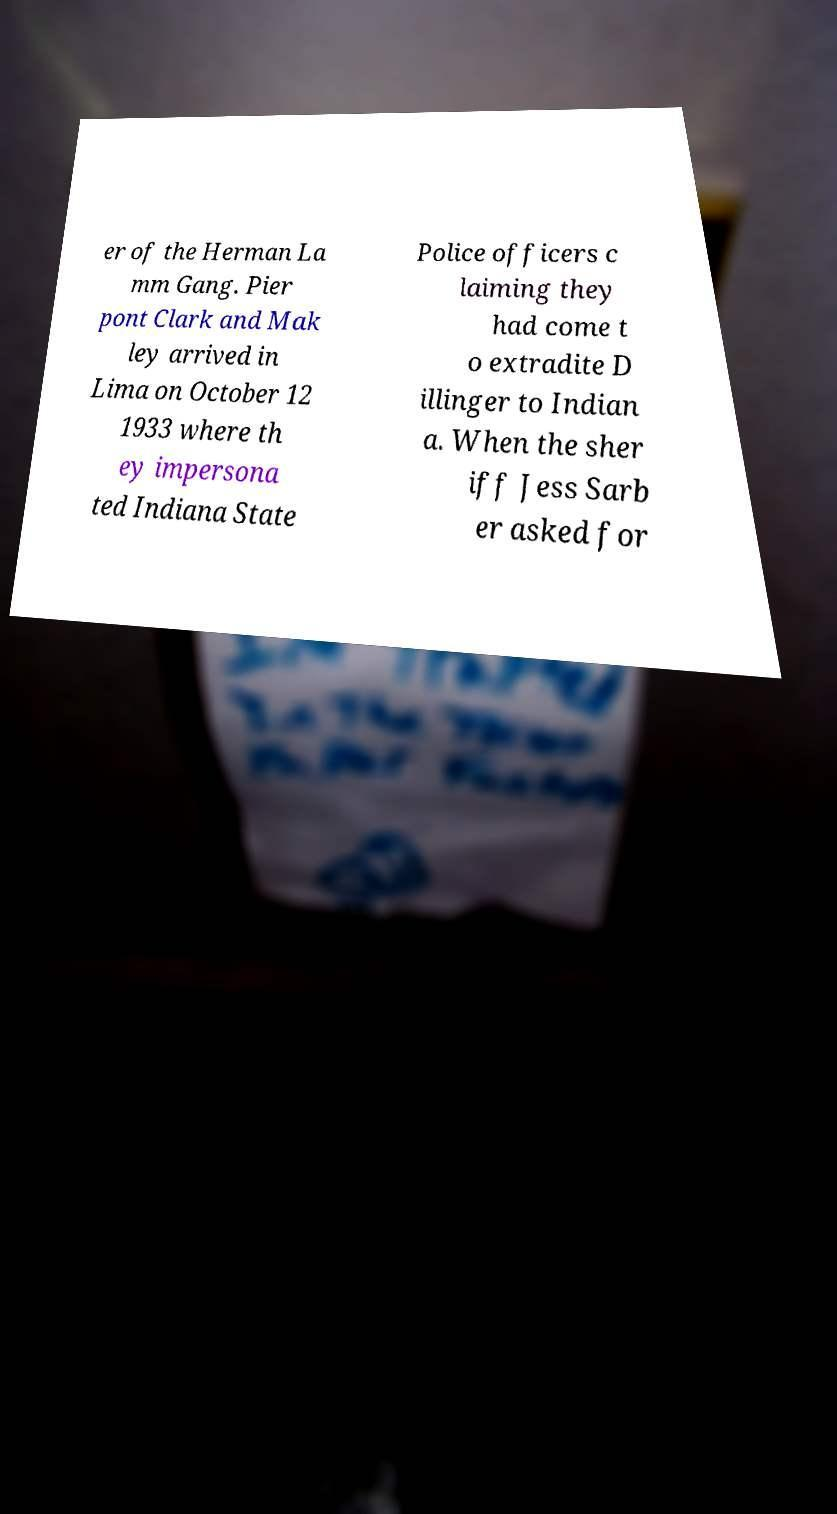For documentation purposes, I need the text within this image transcribed. Could you provide that? er of the Herman La mm Gang. Pier pont Clark and Mak ley arrived in Lima on October 12 1933 where th ey impersona ted Indiana State Police officers c laiming they had come t o extradite D illinger to Indian a. When the sher iff Jess Sarb er asked for 